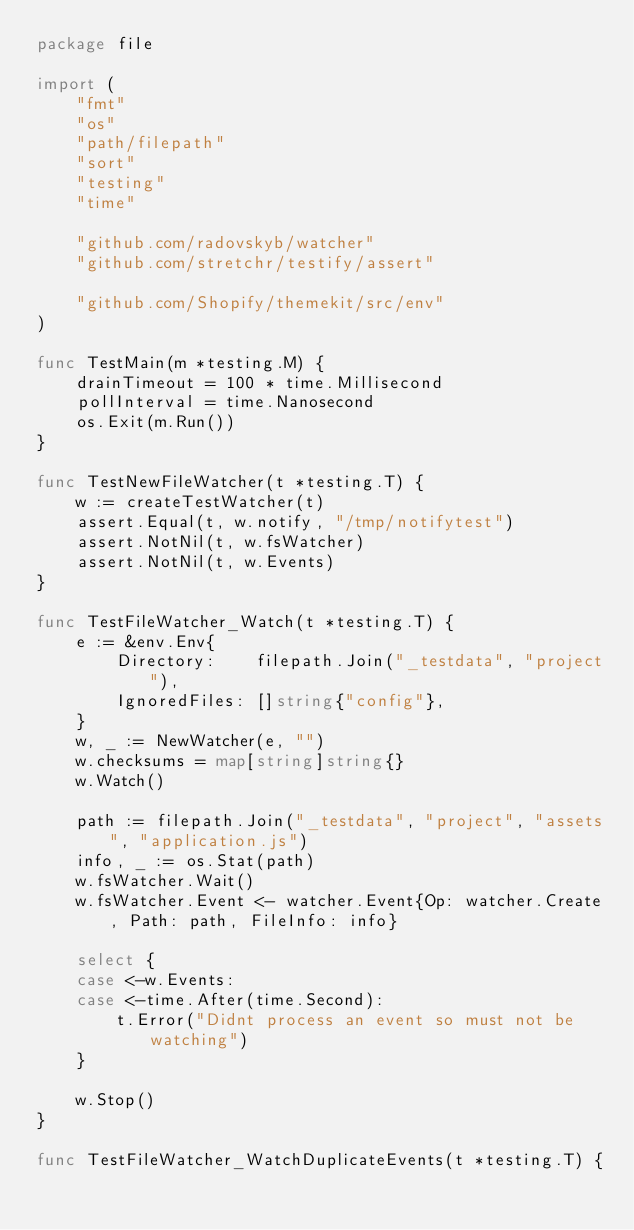<code> <loc_0><loc_0><loc_500><loc_500><_Go_>package file

import (
	"fmt"
	"os"
	"path/filepath"
	"sort"
	"testing"
	"time"

	"github.com/radovskyb/watcher"
	"github.com/stretchr/testify/assert"

	"github.com/Shopify/themekit/src/env"
)

func TestMain(m *testing.M) {
	drainTimeout = 100 * time.Millisecond
	pollInterval = time.Nanosecond
	os.Exit(m.Run())
}

func TestNewFileWatcher(t *testing.T) {
	w := createTestWatcher(t)
	assert.Equal(t, w.notify, "/tmp/notifytest")
	assert.NotNil(t, w.fsWatcher)
	assert.NotNil(t, w.Events)
}

func TestFileWatcher_Watch(t *testing.T) {
	e := &env.Env{
		Directory:    filepath.Join("_testdata", "project"),
		IgnoredFiles: []string{"config"},
	}
	w, _ := NewWatcher(e, "")
	w.checksums = map[string]string{}
	w.Watch()

	path := filepath.Join("_testdata", "project", "assets", "application.js")
	info, _ := os.Stat(path)
	w.fsWatcher.Wait()
	w.fsWatcher.Event <- watcher.Event{Op: watcher.Create, Path: path, FileInfo: info}

	select {
	case <-w.Events:
	case <-time.After(time.Second):
		t.Error("Didnt process an event so must not be watching")
	}

	w.Stop()
}

func TestFileWatcher_WatchDuplicateEvents(t *testing.T) {</code> 